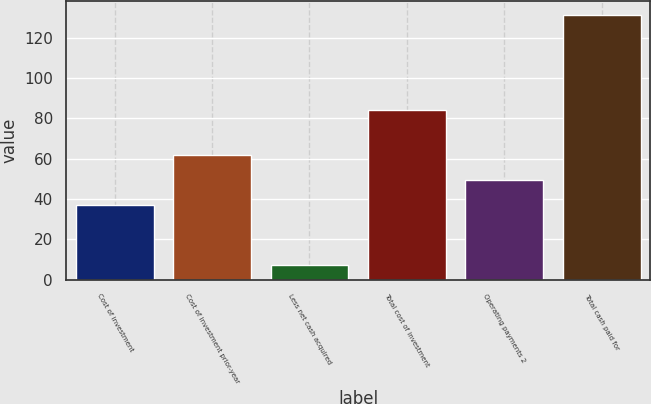<chart> <loc_0><loc_0><loc_500><loc_500><bar_chart><fcel>Cost of investment<fcel>Cost of investment prior-year<fcel>Less net cash acquired<fcel>Total cost of investment<fcel>Operating payments 2<fcel>Total cash paid for<nl><fcel>36.8<fcel>61.66<fcel>7.1<fcel>84.3<fcel>49.23<fcel>131.4<nl></chart> 